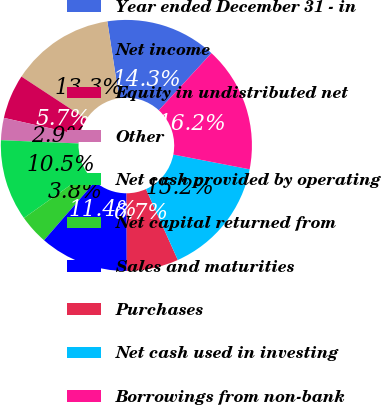Convert chart. <chart><loc_0><loc_0><loc_500><loc_500><pie_chart><fcel>Year ended December 31 - in<fcel>Net income<fcel>Equity in undistributed net<fcel>Other<fcel>Net cash provided by operating<fcel>Net capital returned from<fcel>Sales and maturities<fcel>Purchases<fcel>Net cash used in investing<fcel>Borrowings from non-bank<nl><fcel>14.28%<fcel>13.33%<fcel>5.72%<fcel>2.86%<fcel>10.48%<fcel>3.81%<fcel>11.43%<fcel>6.67%<fcel>15.24%<fcel>16.19%<nl></chart> 